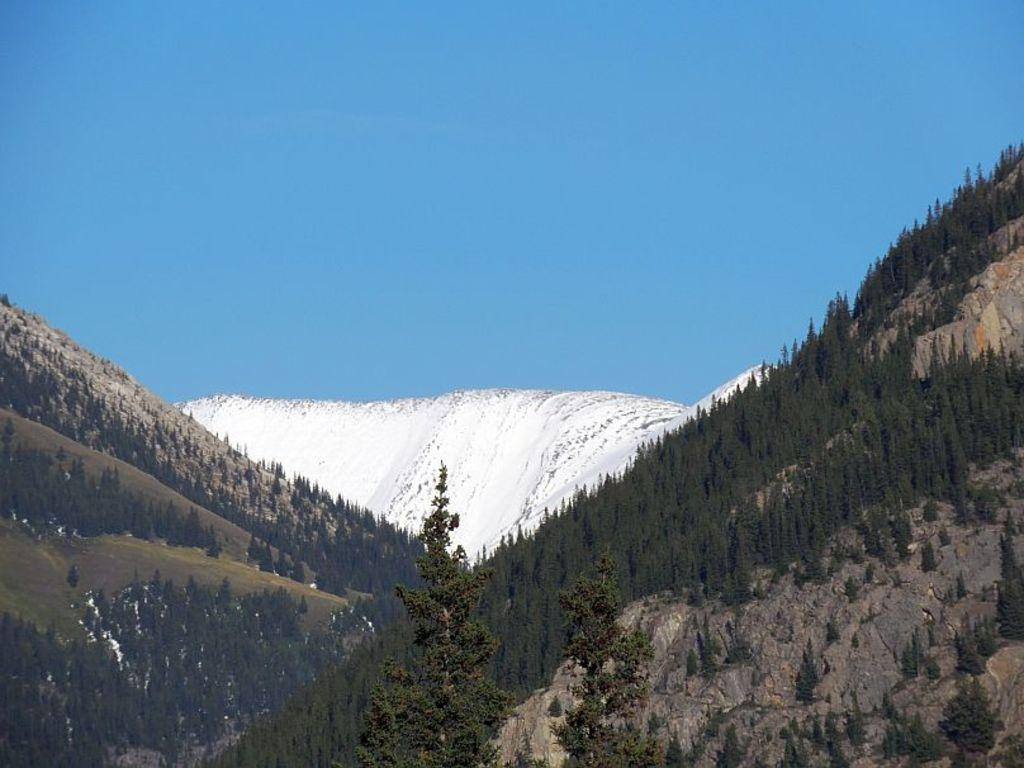What type of vegetation can be seen in the image? There are trees in the image. What is the color of the trees? The trees are green in color. What can be seen in the background of the image? There is snow in the background of the image. What is the color of the snow? The snow is white in color. What is the color of the sky in the image? The sky is blue in color. What type of relation does the father have with the trees in the image? There is no father or relation mentioned in the image; it only features trees, snow, and a blue sky. 